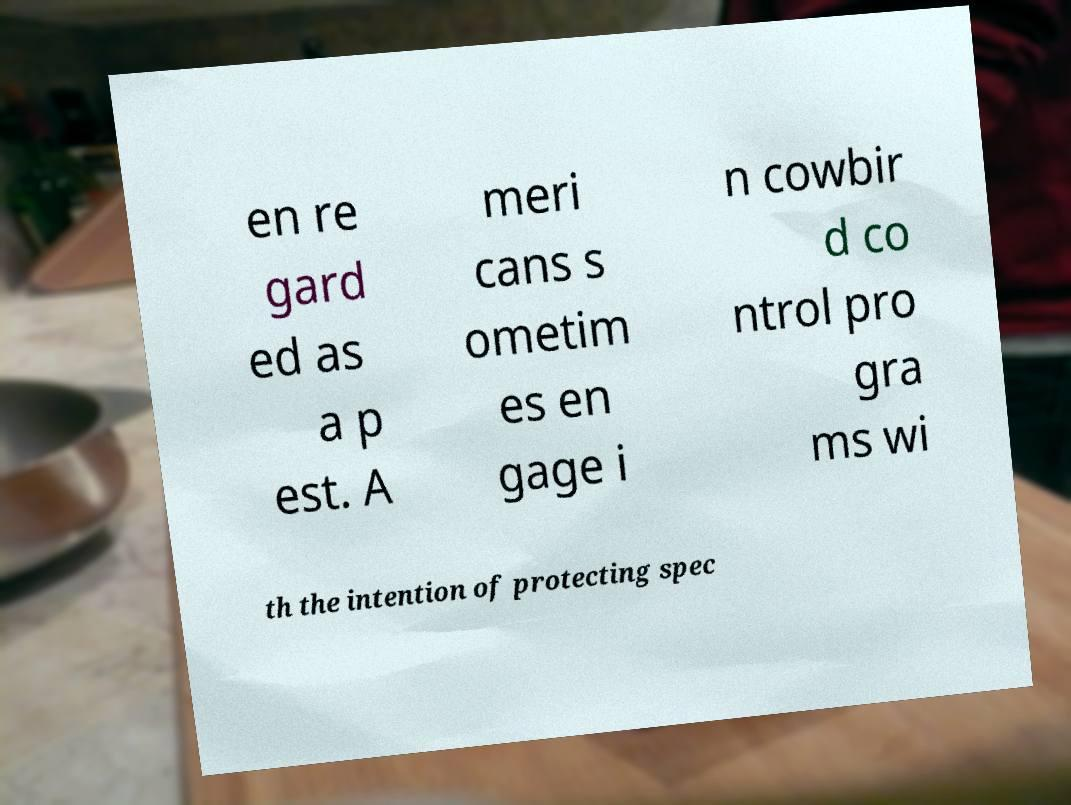Can you accurately transcribe the text from the provided image for me? en re gard ed as a p est. A meri cans s ometim es en gage i n cowbir d co ntrol pro gra ms wi th the intention of protecting spec 